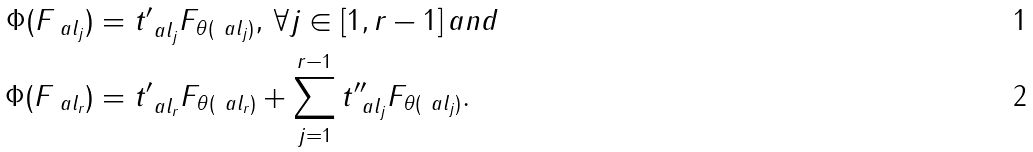Convert formula to latex. <formula><loc_0><loc_0><loc_500><loc_500>\Phi ( F _ { \ a l _ { j } } ) & = t ^ { \prime } _ { \ a l _ { j } } F _ { \theta ( \ a l _ { j } ) } , \, \forall j \in [ 1 , r - 1 ] \, a n d \\ \Phi ( F _ { \ a l _ { r } } ) & = t ^ { \prime } _ { \ a l _ { r } } F _ { \theta ( \ a l _ { r } ) } + \sum _ { j = 1 } ^ { r - 1 } t ^ { \prime \prime } _ { \ a l _ { j } } F _ { \theta ( \ a l _ { j } ) } .</formula> 